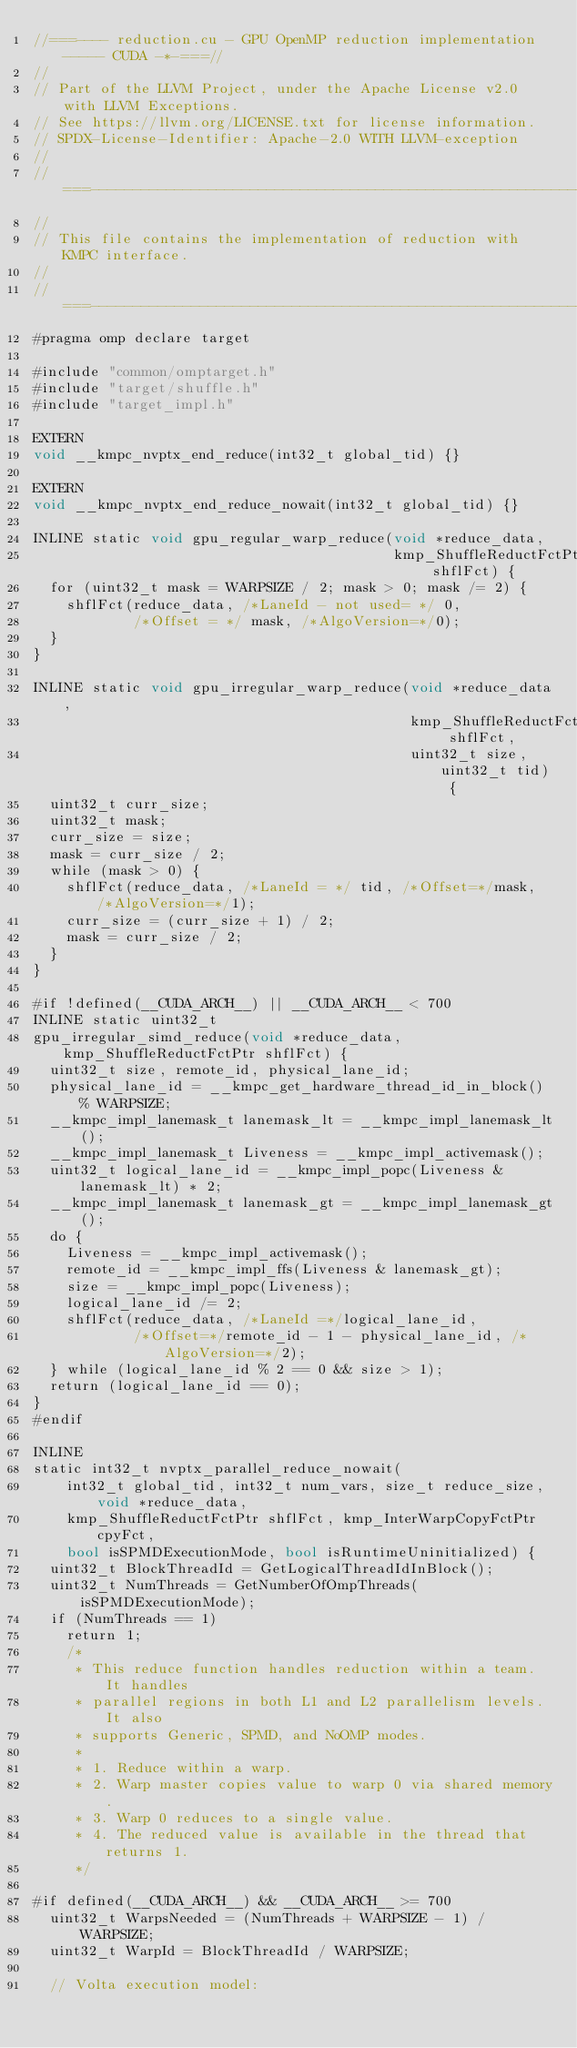<code> <loc_0><loc_0><loc_500><loc_500><_Cuda_>//===---- reduction.cu - GPU OpenMP reduction implementation ----- CUDA -*-===//
//
// Part of the LLVM Project, under the Apache License v2.0 with LLVM Exceptions.
// See https://llvm.org/LICENSE.txt for license information.
// SPDX-License-Identifier: Apache-2.0 WITH LLVM-exception
//
//===----------------------------------------------------------------------===//
//
// This file contains the implementation of reduction with KMPC interface.
//
//===----------------------------------------------------------------------===//
#pragma omp declare target

#include "common/omptarget.h"
#include "target/shuffle.h"
#include "target_impl.h"

EXTERN
void __kmpc_nvptx_end_reduce(int32_t global_tid) {}

EXTERN
void __kmpc_nvptx_end_reduce_nowait(int32_t global_tid) {}

INLINE static void gpu_regular_warp_reduce(void *reduce_data,
                                           kmp_ShuffleReductFctPtr shflFct) {
  for (uint32_t mask = WARPSIZE / 2; mask > 0; mask /= 2) {
    shflFct(reduce_data, /*LaneId - not used= */ 0,
            /*Offset = */ mask, /*AlgoVersion=*/0);
  }
}

INLINE static void gpu_irregular_warp_reduce(void *reduce_data,
                                             kmp_ShuffleReductFctPtr shflFct,
                                             uint32_t size, uint32_t tid) {
  uint32_t curr_size;
  uint32_t mask;
  curr_size = size;
  mask = curr_size / 2;
  while (mask > 0) {
    shflFct(reduce_data, /*LaneId = */ tid, /*Offset=*/mask, /*AlgoVersion=*/1);
    curr_size = (curr_size + 1) / 2;
    mask = curr_size / 2;
  }
}

#if !defined(__CUDA_ARCH__) || __CUDA_ARCH__ < 700
INLINE static uint32_t
gpu_irregular_simd_reduce(void *reduce_data, kmp_ShuffleReductFctPtr shflFct) {
  uint32_t size, remote_id, physical_lane_id;
  physical_lane_id = __kmpc_get_hardware_thread_id_in_block() % WARPSIZE;
  __kmpc_impl_lanemask_t lanemask_lt = __kmpc_impl_lanemask_lt();
  __kmpc_impl_lanemask_t Liveness = __kmpc_impl_activemask();
  uint32_t logical_lane_id = __kmpc_impl_popc(Liveness & lanemask_lt) * 2;
  __kmpc_impl_lanemask_t lanemask_gt = __kmpc_impl_lanemask_gt();
  do {
    Liveness = __kmpc_impl_activemask();
    remote_id = __kmpc_impl_ffs(Liveness & lanemask_gt);
    size = __kmpc_impl_popc(Liveness);
    logical_lane_id /= 2;
    shflFct(reduce_data, /*LaneId =*/logical_lane_id,
            /*Offset=*/remote_id - 1 - physical_lane_id, /*AlgoVersion=*/2);
  } while (logical_lane_id % 2 == 0 && size > 1);
  return (logical_lane_id == 0);
}
#endif

INLINE
static int32_t nvptx_parallel_reduce_nowait(
    int32_t global_tid, int32_t num_vars, size_t reduce_size, void *reduce_data,
    kmp_ShuffleReductFctPtr shflFct, kmp_InterWarpCopyFctPtr cpyFct,
    bool isSPMDExecutionMode, bool isRuntimeUninitialized) {
  uint32_t BlockThreadId = GetLogicalThreadIdInBlock();
  uint32_t NumThreads = GetNumberOfOmpThreads(isSPMDExecutionMode);
  if (NumThreads == 1)
    return 1;
    /*
     * This reduce function handles reduction within a team. It handles
     * parallel regions in both L1 and L2 parallelism levels. It also
     * supports Generic, SPMD, and NoOMP modes.
     *
     * 1. Reduce within a warp.
     * 2. Warp master copies value to warp 0 via shared memory.
     * 3. Warp 0 reduces to a single value.
     * 4. The reduced value is available in the thread that returns 1.
     */

#if defined(__CUDA_ARCH__) && __CUDA_ARCH__ >= 700
  uint32_t WarpsNeeded = (NumThreads + WARPSIZE - 1) / WARPSIZE;
  uint32_t WarpId = BlockThreadId / WARPSIZE;

  // Volta execution model:</code> 